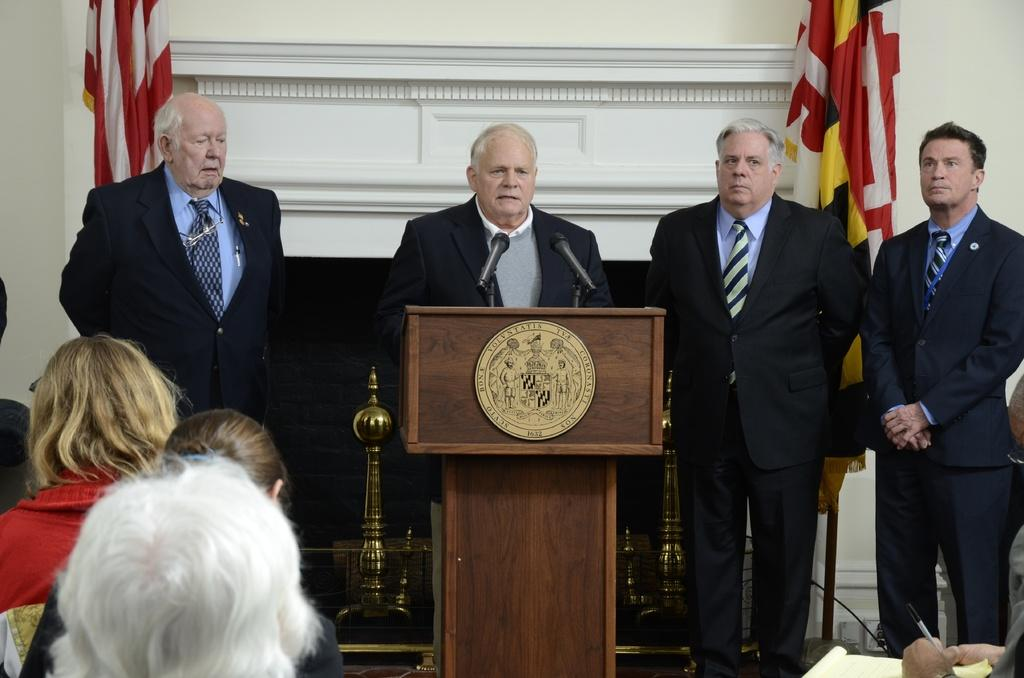What are the people on the dais doing in the image? The people standing on the dais are likely giving a presentation or speech. What are the people sitting in front of the dais doing? The people sitting in front of the dais are likely listening to the presentation or speech. What can be seen in the background of the image? There is a wall in the background of the image. What type of airplane is visible in the image? There is no airplane present in the image; it features people standing on a dais and people sitting in chairs. Can you tell me what the people on the dais are writing on their notepads? There is no indication that the people on the dais are writing on notepads in the image. 